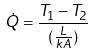Convert formula to latex. <formula><loc_0><loc_0><loc_500><loc_500>\dot { Q } = \frac { T _ { 1 } - T _ { 2 } } { ( \frac { L } { k A } ) }</formula> 